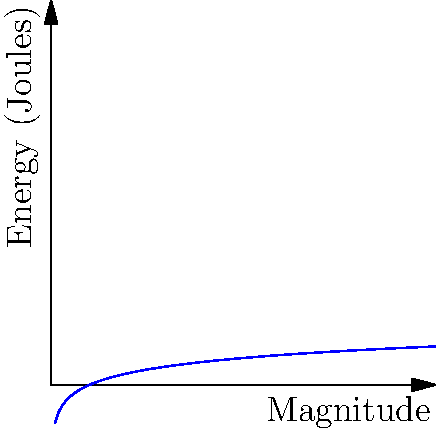The graph shows the relationship between earthquake magnitude and energy release on a logarithmic scale. Given that the 2010 Haiti earthquake had a magnitude of 7.0 and the 2010 Chile earthquake had a magnitude of 8.8, approximately how many times more energy did the Chile earthquake release compared to the Haiti earthquake? To solve this problem, we'll follow these steps:

1) The energy released in an earthquake is related to its magnitude by the formula:
   $$\log_{10}(E) = 1.5M + 4.8$$
   where E is energy in joules and M is magnitude.

2) For the Haiti earthquake (M = 7.0):
   $$\log_{10}(E_H) = 1.5(7.0) + 4.8 = 15.3$$

3) For the Chile earthquake (M = 8.8):
   $$\log_{10}(E_C) = 1.5(8.8) + 4.8 = 18$$

4) To find the ratio of energies, we subtract:
   $$\log_{10}(E_C) - \log_{10}(E_H) = 18 - 15.3 = 2.7$$

5) This difference in logarithms means:
   $$\log_{10}(E_C/E_H) = 2.7$$

6) To get the ratio, we take 10 to the power of both sides:
   $$E_C/E_H = 10^{2.7} \approx 501$$

Therefore, the Chile earthquake released approximately 501 times more energy than the Haiti earthquake.
Answer: 501 times 